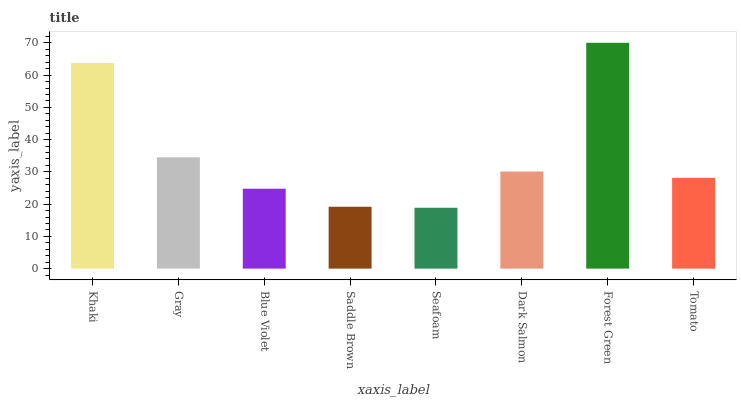Is Seafoam the minimum?
Answer yes or no. Yes. Is Forest Green the maximum?
Answer yes or no. Yes. Is Gray the minimum?
Answer yes or no. No. Is Gray the maximum?
Answer yes or no. No. Is Khaki greater than Gray?
Answer yes or no. Yes. Is Gray less than Khaki?
Answer yes or no. Yes. Is Gray greater than Khaki?
Answer yes or no. No. Is Khaki less than Gray?
Answer yes or no. No. Is Dark Salmon the high median?
Answer yes or no. Yes. Is Tomato the low median?
Answer yes or no. Yes. Is Seafoam the high median?
Answer yes or no. No. Is Seafoam the low median?
Answer yes or no. No. 